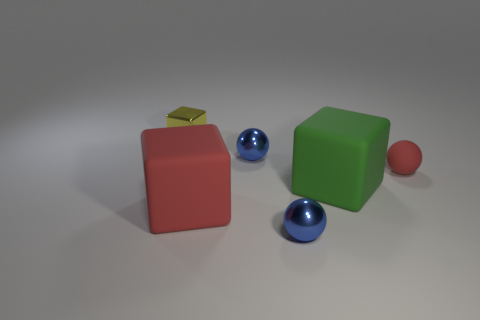Add 2 small matte things. How many objects exist? 8 Subtract 0 purple cylinders. How many objects are left? 6 Subtract all matte cubes. Subtract all small red things. How many objects are left? 3 Add 2 yellow objects. How many yellow objects are left? 3 Add 6 big red rubber spheres. How many big red rubber spheres exist? 6 